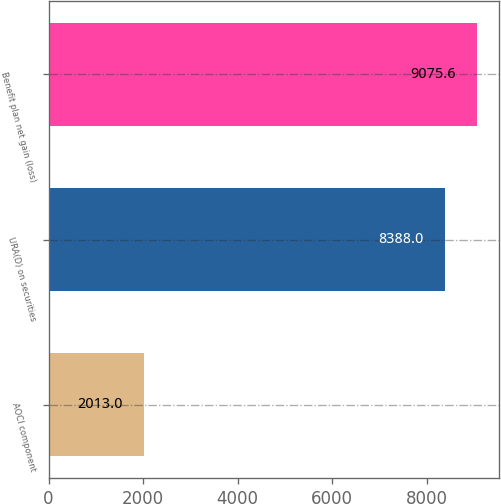Convert chart. <chart><loc_0><loc_0><loc_500><loc_500><bar_chart><fcel>AOCI component<fcel>URA(D) on securities<fcel>Benefit plan net gain (loss)<nl><fcel>2013<fcel>8388<fcel>9075.6<nl></chart> 